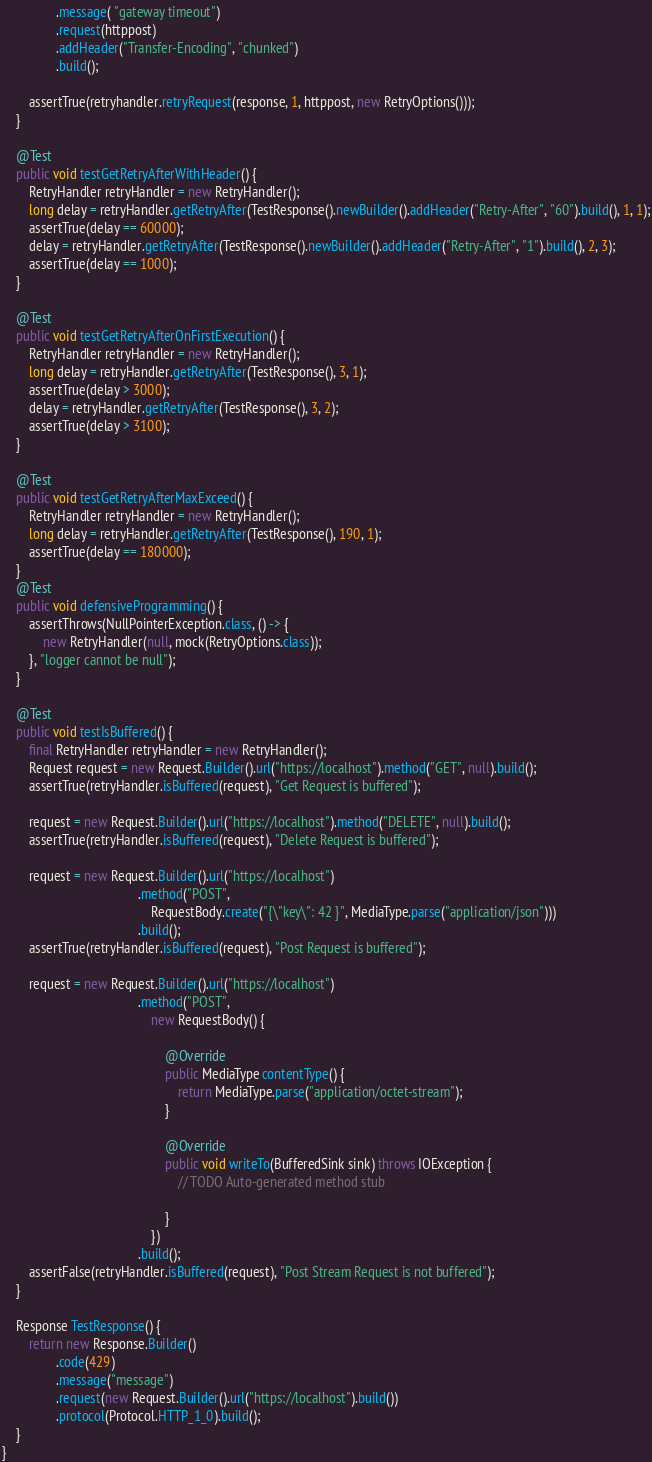<code> <loc_0><loc_0><loc_500><loc_500><_Java_>                .message( "gateway timeout")
                .request(httppost)
                .addHeader("Transfer-Encoding", "chunked")
                .build();

        assertTrue(retryhandler.retryRequest(response, 1, httppost, new RetryOptions()));
    }

    @Test
    public void testGetRetryAfterWithHeader() {
        RetryHandler retryHandler = new RetryHandler();
        long delay = retryHandler.getRetryAfter(TestResponse().newBuilder().addHeader("Retry-After", "60").build(), 1, 1);
        assertTrue(delay == 60000);
        delay = retryHandler.getRetryAfter(TestResponse().newBuilder().addHeader("Retry-After", "1").build(), 2, 3);
        assertTrue(delay == 1000);
    }

    @Test
    public void testGetRetryAfterOnFirstExecution() {
        RetryHandler retryHandler = new RetryHandler();
        long delay = retryHandler.getRetryAfter(TestResponse(), 3, 1);
        assertTrue(delay > 3000);
        delay = retryHandler.getRetryAfter(TestResponse(), 3, 2);
        assertTrue(delay > 3100);
    }

    @Test
    public void testGetRetryAfterMaxExceed() {
        RetryHandler retryHandler = new RetryHandler();
        long delay = retryHandler.getRetryAfter(TestResponse(), 190, 1);
        assertTrue(delay == 180000);
    }
    @Test
    public void defensiveProgramming() {
        assertThrows(NullPointerException.class, () -> {
            new RetryHandler(null, mock(RetryOptions.class));
        }, "logger cannot be null");
    }

    @Test
    public void testIsBuffered() {
        final RetryHandler retryHandler = new RetryHandler();
        Request request = new Request.Builder().url("https://localhost").method("GET", null).build();
        assertTrue(retryHandler.isBuffered(request), "Get Request is buffered");

        request = new Request.Builder().url("https://localhost").method("DELETE", null).build();
        assertTrue(retryHandler.isBuffered(request), "Delete Request is buffered");

        request = new Request.Builder().url("https://localhost")
                                        .method("POST",
                                            RequestBody.create("{\"key\": 42 }", MediaType.parse("application/json")))
                                        .build();
        assertTrue(retryHandler.isBuffered(request), "Post Request is buffered");

        request = new Request.Builder().url("https://localhost")
                                        .method("POST",
                                            new RequestBody() {

                                                @Override
                                                public MediaType contentType() {
                                                    return MediaType.parse("application/octet-stream");
                                                }

                                                @Override
                                                public void writeTo(BufferedSink sink) throws IOException {
                                                    // TODO Auto-generated method stub

                                                }
                                            })
                                        .build();
        assertFalse(retryHandler.isBuffered(request), "Post Stream Request is not buffered");
    }

    Response TestResponse() {
        return new Response.Builder()
                .code(429)
                .message("message")
                .request(new Request.Builder().url("https://localhost").build())
                .protocol(Protocol.HTTP_1_0).build();
    }
}
</code> 